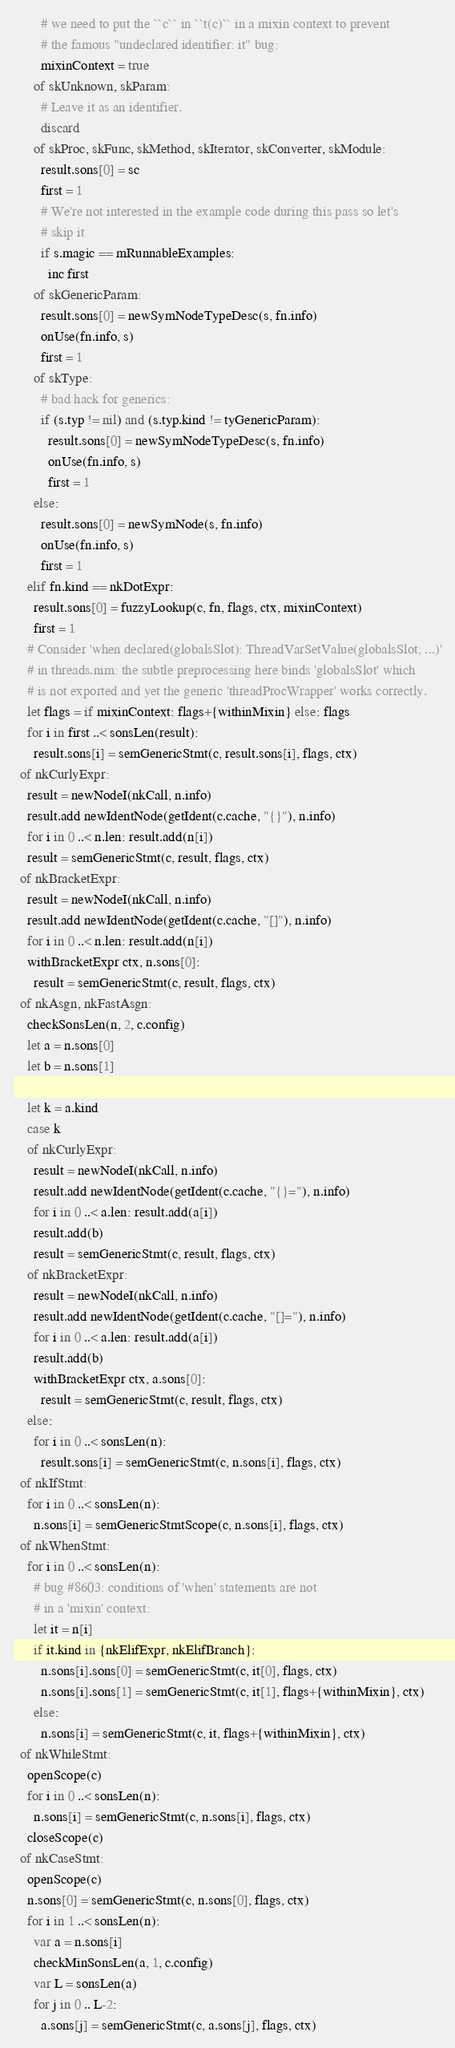<code> <loc_0><loc_0><loc_500><loc_500><_Nim_>        # we need to put the ``c`` in ``t(c)`` in a mixin context to prevent
        # the famous "undeclared identifier: it" bug:
        mixinContext = true
      of skUnknown, skParam:
        # Leave it as an identifier.
        discard
      of skProc, skFunc, skMethod, skIterator, skConverter, skModule:
        result.sons[0] = sc
        first = 1
        # We're not interested in the example code during this pass so let's
        # skip it
        if s.magic == mRunnableExamples:
          inc first
      of skGenericParam:
        result.sons[0] = newSymNodeTypeDesc(s, fn.info)
        onUse(fn.info, s)
        first = 1
      of skType:
        # bad hack for generics:
        if (s.typ != nil) and (s.typ.kind != tyGenericParam):
          result.sons[0] = newSymNodeTypeDesc(s, fn.info)
          onUse(fn.info, s)
          first = 1
      else:
        result.sons[0] = newSymNode(s, fn.info)
        onUse(fn.info, s)
        first = 1
    elif fn.kind == nkDotExpr:
      result.sons[0] = fuzzyLookup(c, fn, flags, ctx, mixinContext)
      first = 1
    # Consider 'when declared(globalsSlot): ThreadVarSetValue(globalsSlot, ...)'
    # in threads.nim: the subtle preprocessing here binds 'globalsSlot' which
    # is not exported and yet the generic 'threadProcWrapper' works correctly.
    let flags = if mixinContext: flags+{withinMixin} else: flags
    for i in first ..< sonsLen(result):
      result.sons[i] = semGenericStmt(c, result.sons[i], flags, ctx)
  of nkCurlyExpr:
    result = newNodeI(nkCall, n.info)
    result.add newIdentNode(getIdent(c.cache, "{}"), n.info)
    for i in 0 ..< n.len: result.add(n[i])
    result = semGenericStmt(c, result, flags, ctx)
  of nkBracketExpr:
    result = newNodeI(nkCall, n.info)
    result.add newIdentNode(getIdent(c.cache, "[]"), n.info)
    for i in 0 ..< n.len: result.add(n[i])
    withBracketExpr ctx, n.sons[0]:
      result = semGenericStmt(c, result, flags, ctx)
  of nkAsgn, nkFastAsgn:
    checkSonsLen(n, 2, c.config)
    let a = n.sons[0]
    let b = n.sons[1]

    let k = a.kind
    case k
    of nkCurlyExpr:
      result = newNodeI(nkCall, n.info)
      result.add newIdentNode(getIdent(c.cache, "{}="), n.info)
      for i in 0 ..< a.len: result.add(a[i])
      result.add(b)
      result = semGenericStmt(c, result, flags, ctx)
    of nkBracketExpr:
      result = newNodeI(nkCall, n.info)
      result.add newIdentNode(getIdent(c.cache, "[]="), n.info)
      for i in 0 ..< a.len: result.add(a[i])
      result.add(b)
      withBracketExpr ctx, a.sons[0]:
        result = semGenericStmt(c, result, flags, ctx)
    else:
      for i in 0 ..< sonsLen(n):
        result.sons[i] = semGenericStmt(c, n.sons[i], flags, ctx)
  of nkIfStmt:
    for i in 0 ..< sonsLen(n):
      n.sons[i] = semGenericStmtScope(c, n.sons[i], flags, ctx)
  of nkWhenStmt:
    for i in 0 ..< sonsLen(n):
      # bug #8603: conditions of 'when' statements are not
      # in a 'mixin' context:
      let it = n[i]
      if it.kind in {nkElifExpr, nkElifBranch}:
        n.sons[i].sons[0] = semGenericStmt(c, it[0], flags, ctx)
        n.sons[i].sons[1] = semGenericStmt(c, it[1], flags+{withinMixin}, ctx)
      else:
        n.sons[i] = semGenericStmt(c, it, flags+{withinMixin}, ctx)
  of nkWhileStmt:
    openScope(c)
    for i in 0 ..< sonsLen(n):
      n.sons[i] = semGenericStmt(c, n.sons[i], flags, ctx)
    closeScope(c)
  of nkCaseStmt:
    openScope(c)
    n.sons[0] = semGenericStmt(c, n.sons[0], flags, ctx)
    for i in 1 ..< sonsLen(n):
      var a = n.sons[i]
      checkMinSonsLen(a, 1, c.config)
      var L = sonsLen(a)
      for j in 0 .. L-2:
        a.sons[j] = semGenericStmt(c, a.sons[j], flags, ctx)</code> 